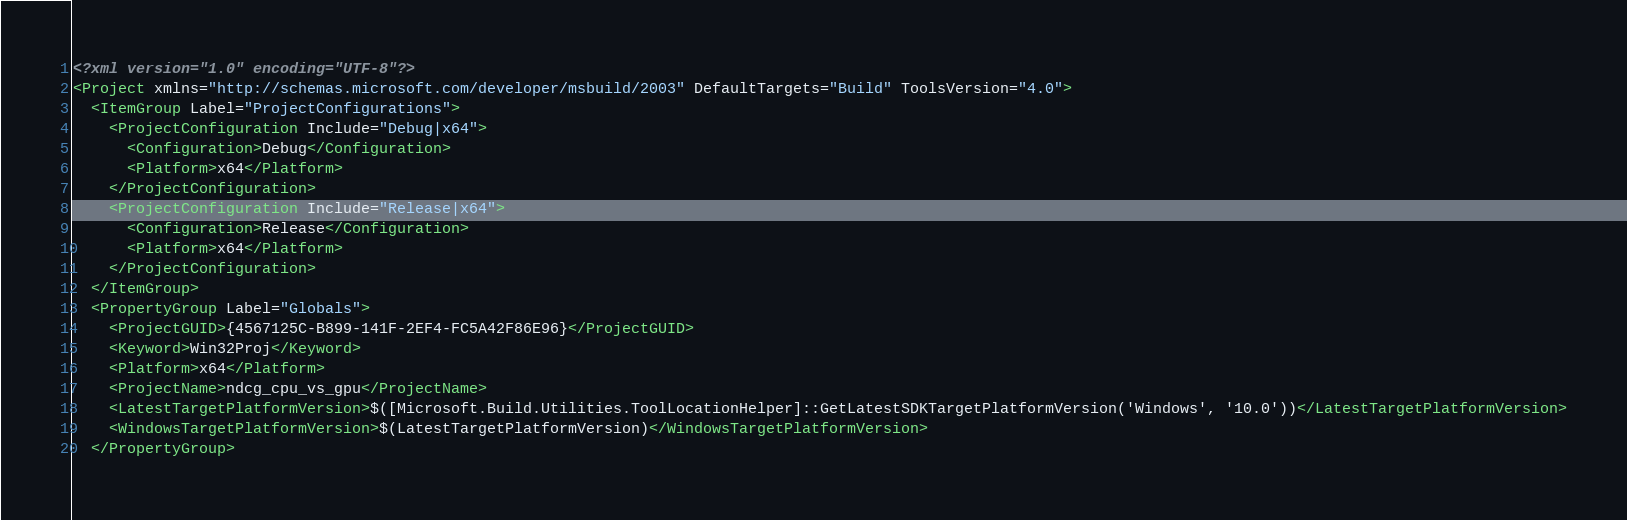Convert code to text. <code><loc_0><loc_0><loc_500><loc_500><_XML_><?xml version="1.0" encoding="UTF-8"?>
<Project xmlns="http://schemas.microsoft.com/developer/msbuild/2003" DefaultTargets="Build" ToolsVersion="4.0">
  <ItemGroup Label="ProjectConfigurations">
    <ProjectConfiguration Include="Debug|x64">
      <Configuration>Debug</Configuration>
      <Platform>x64</Platform>
    </ProjectConfiguration>
    <ProjectConfiguration Include="Release|x64">
      <Configuration>Release</Configuration>
      <Platform>x64</Platform>
    </ProjectConfiguration>
  </ItemGroup>
  <PropertyGroup Label="Globals">
    <ProjectGUID>{4567125C-B899-141F-2EF4-FC5A42F86E96}</ProjectGUID>
    <Keyword>Win32Proj</Keyword>
    <Platform>x64</Platform>
    <ProjectName>ndcg_cpu_vs_gpu</ProjectName>
    <LatestTargetPlatformVersion>$([Microsoft.Build.Utilities.ToolLocationHelper]::GetLatestSDKTargetPlatformVersion('Windows', '10.0'))</LatestTargetPlatformVersion>
    <WindowsTargetPlatformVersion>$(LatestTargetPlatformVersion)</WindowsTargetPlatformVersion>
  </PropertyGroup></code> 